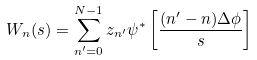Convert formula to latex. <formula><loc_0><loc_0><loc_500><loc_500>W _ { n } ( s ) = \sum ^ { N - 1 } _ { n ^ { \prime } = 0 } z _ { n ^ { \prime } } \psi ^ { * } \left [ \frac { ( n ^ { \prime } - n ) \Delta \phi } { s } \right ]</formula> 